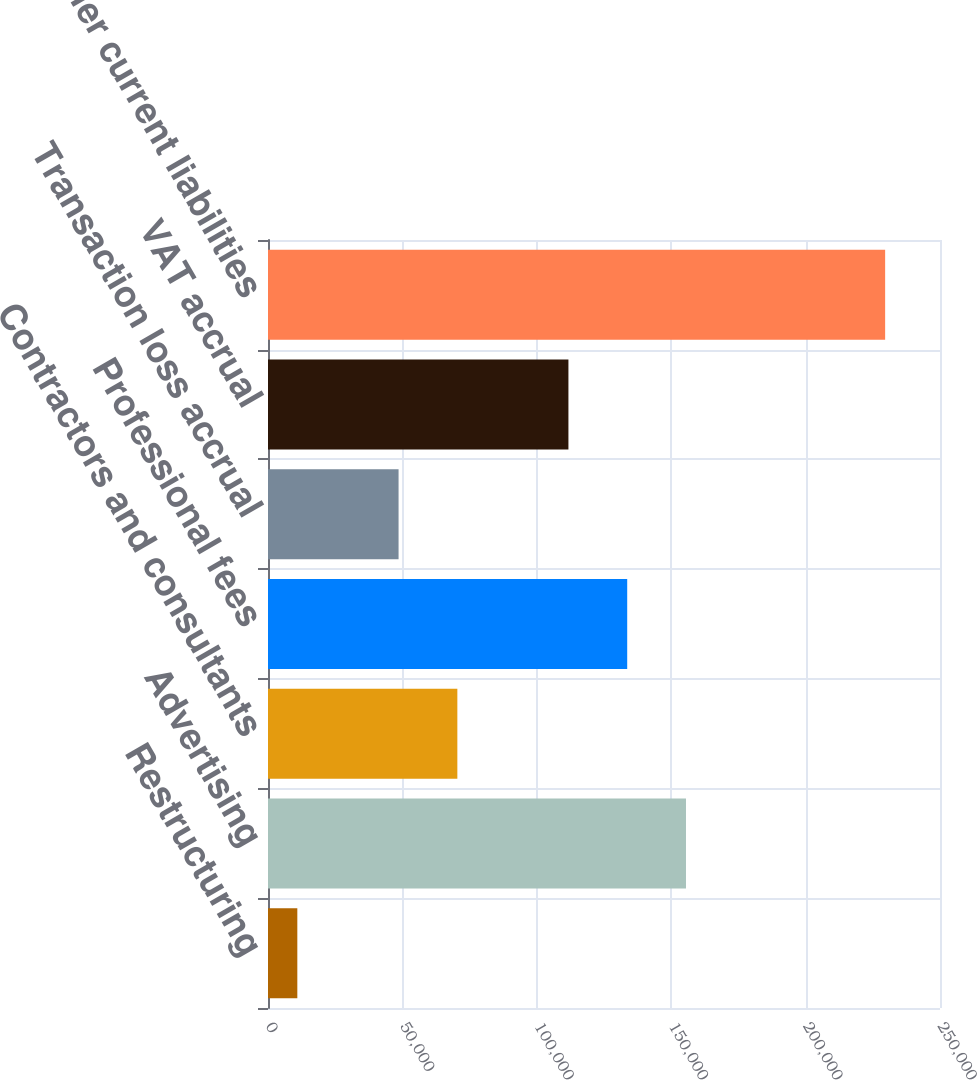Convert chart. <chart><loc_0><loc_0><loc_500><loc_500><bar_chart><fcel>Restructuring<fcel>Advertising<fcel>Contractors and consultants<fcel>Professional fees<fcel>Transaction loss accrual<fcel>VAT accrual<fcel>Other current liabilities<nl><fcel>10909<fcel>155501<fcel>70443.2<fcel>133633<fcel>48575<fcel>111765<fcel>229591<nl></chart> 